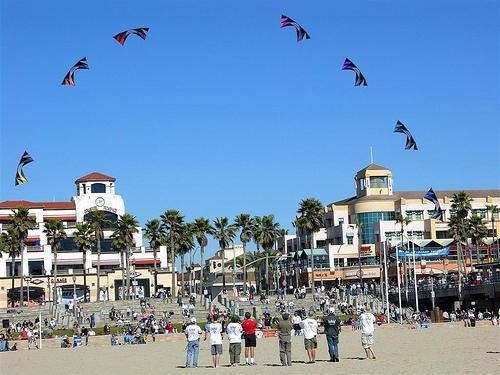The items the people are staring at are likely made of what?

Choices:
A) mud
B) cloth
C) brick
D) stone cloth 